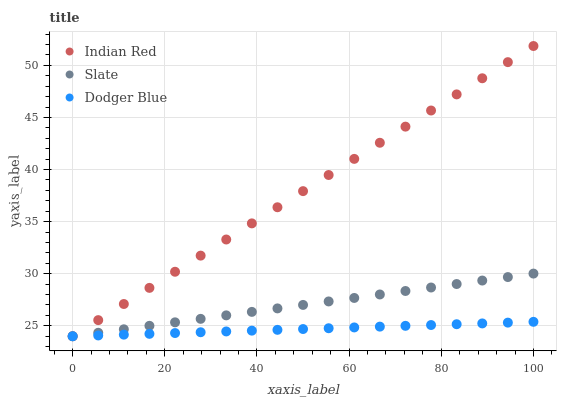Does Dodger Blue have the minimum area under the curve?
Answer yes or no. Yes. Does Indian Red have the maximum area under the curve?
Answer yes or no. Yes. Does Indian Red have the minimum area under the curve?
Answer yes or no. No. Does Dodger Blue have the maximum area under the curve?
Answer yes or no. No. Is Dodger Blue the smoothest?
Answer yes or no. Yes. Is Indian Red the roughest?
Answer yes or no. Yes. Is Indian Red the smoothest?
Answer yes or no. No. Is Dodger Blue the roughest?
Answer yes or no. No. Does Slate have the lowest value?
Answer yes or no. Yes. Does Indian Red have the highest value?
Answer yes or no. Yes. Does Dodger Blue have the highest value?
Answer yes or no. No. Does Indian Red intersect Slate?
Answer yes or no. Yes. Is Indian Red less than Slate?
Answer yes or no. No. Is Indian Red greater than Slate?
Answer yes or no. No. 